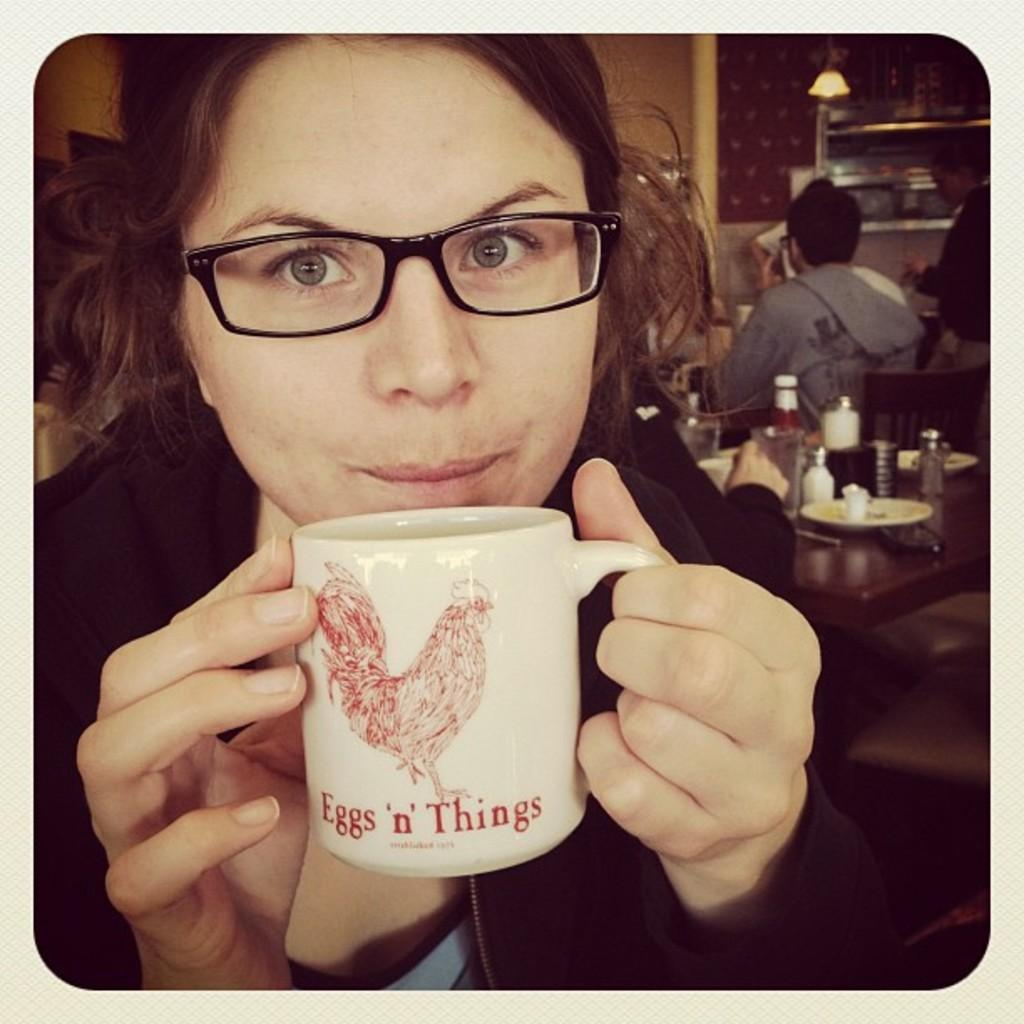<image>
Give a short and clear explanation of the subsequent image. A woman is holding a mug that says Eggs n Things to her mouth. 